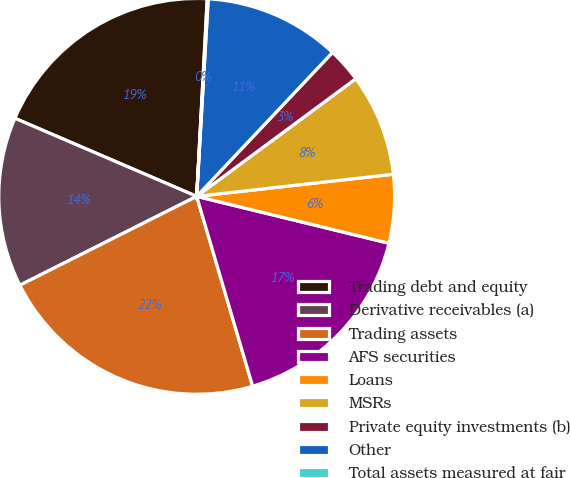<chart> <loc_0><loc_0><loc_500><loc_500><pie_chart><fcel>Trading debt and equity<fcel>Derivative receivables (a)<fcel>Trading assets<fcel>AFS securities<fcel>Loans<fcel>MSRs<fcel>Private equity investments (b)<fcel>Other<fcel>Total assets measured at fair<nl><fcel>19.39%<fcel>13.87%<fcel>22.15%<fcel>16.63%<fcel>5.59%<fcel>8.35%<fcel>2.83%<fcel>11.11%<fcel>0.08%<nl></chart> 